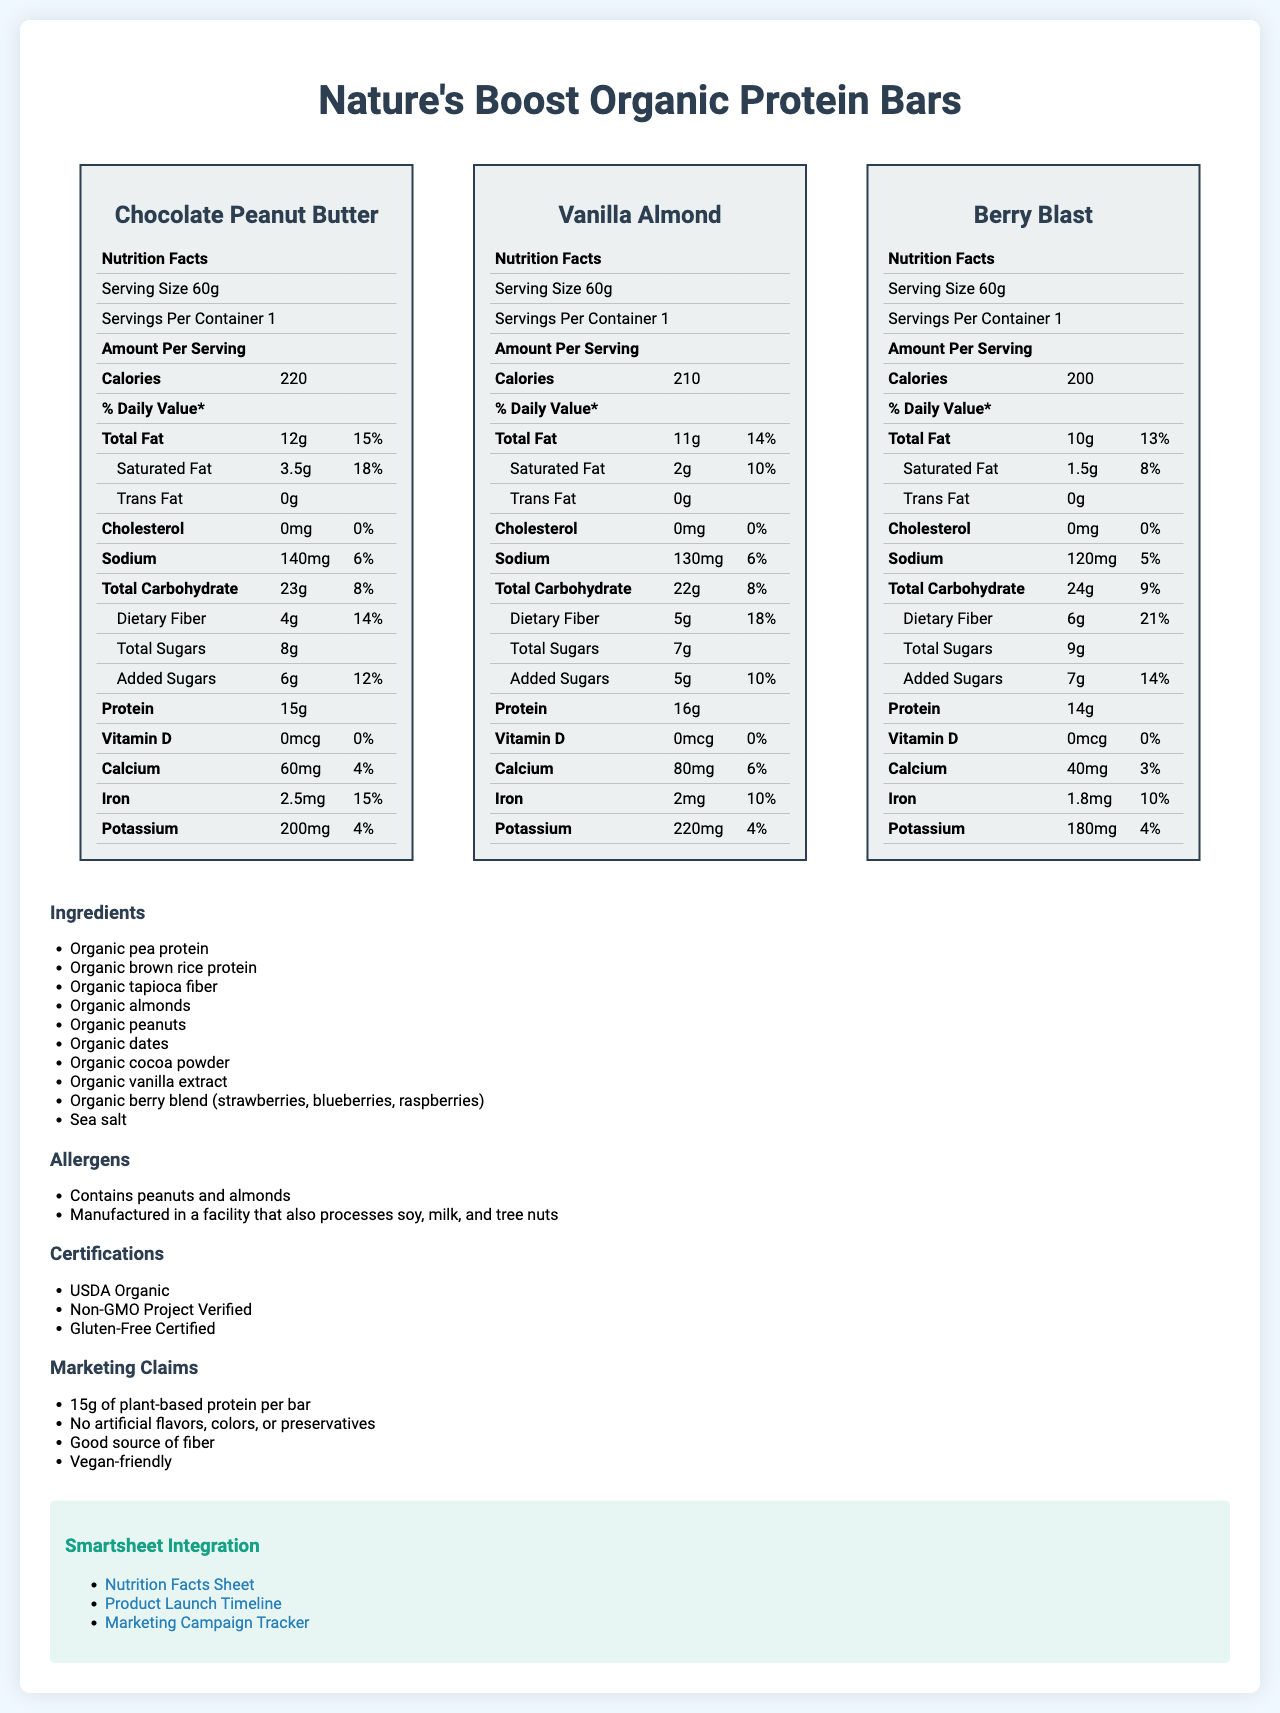what is the total fat content in the Vanilla Almond flavor? The information for total fat is listed under the "Total Fat" row for the Vanilla Almond flavor.
Answer: 11g how many grams of protein are in each Berry Blast bar? The protein content for Berry Blast is provided under the "Protein" row in its nutrition facts.
Answer: 14g what certifications does Nature's Boost Organic Protein Bars have? The certification section lists all the certifications Nature's Boost Organic Protein Bars have.
Answer: USDA Organic, Non-GMO Project Verified, Gluten-Free Certified Which flavor has the highest calorie content? A. Chocolate Peanut Butter B. Vanilla Almond C. Berry Blast Chocolate Peanut Butter has 220 calories, which is higher compared to Vanilla Almond (210) and Berry Blast (200).
Answer: A how much dietary fiber is in the Chocolate Peanut Butter bar? The amount of dietary fiber for the Chocolate Peanut Butter flavor is listed in its nutrition facts under "Dietary Fiber."
Answer: 4g What is the added sugars content in the Berry Blast bar? A. 5g B. 6g C. 7g D. 8g The Berry Blast flavor has 7g of added sugars, as indicated in the "Added Sugars" row.
Answer: C Are these protein bars vegan-friendly? The document mentions "Vegan-friendly" under the "Marketing Claims" section.
Answer: Yes What is the daily value percentage for saturated fat in the Vanilla Almond bar? The percentage daily value for saturated fat for the Vanilla Almond flavor is listed in the document.
Answer: 10% How many serving sizes per container are there for each variant? Each variant lists "Servings Per Container: 1" in their respective nutrition facts section.
Answer: 1 What kind of protein sources are used in these bars? The ingredients section lists "Organic pea protein" and "Organic brown rice protein" as protein sources.
Answer: Organic pea protein, Organic brown rice protein Summarize the main idea of the document. The document gives a comprehensive overview of the nutritional information for three flavors: Chocolate Peanut Butter, Vanilla Almond, and Berry Blast. It also outlines ingredients, allergens, certifications, and key marketing points. Additionally, it includes links to Smartsheet integrations and mentions other connected marketing tools.
Answer: The document provides detailed nutrition facts for three flavors of Nature's Boost Organic Protein Bars, including ingredients, allergens, certifications, and marketing claims. It also mentions integration links with Smartsheet for different purposes and details connected marketing tools. Are the bars safe for someone with a peanut allergy? The allergens section specifically mentions that the bars contain peanuts and almonds.
Answer: No What is the highest percentage daily value of dietary fiber among the variants? The Berry Blast flavor has the highest percentage daily value of dietary fiber at 21%.
Answer: 21% Can the protein bars be described as gluten-free? The certifications section lists "Gluten-Free Certified," indicating the bars are gluten-free.
Answer: Yes What amount of vitamin D is in the Berry Blast bar? The vitamin D amount is listed as 0mcg for the Berry Blast flavor.
Answer: 0mcg Which connected marketing tool is pending integration status? The connected marketing tools section shows that Google Analytics has a "Pending" integration status.
Answer: Google Analytics What is the launch timeline for Nature's Boost product line? The document provides a link to the "product_launch_timeline" in Smartsheet, but the specific details of the timeline are not included in the visual information.
Answer: Cannot be determined What flavors of the protein bars are mentioned? A. Berry Blast B. Vanilla Almond C. Chocolate Peanut Butter D. All of the above The document mentions all three flavors: Berry Blast, Vanilla Almond, and Chocolate Peanut Butter.
Answer: D 